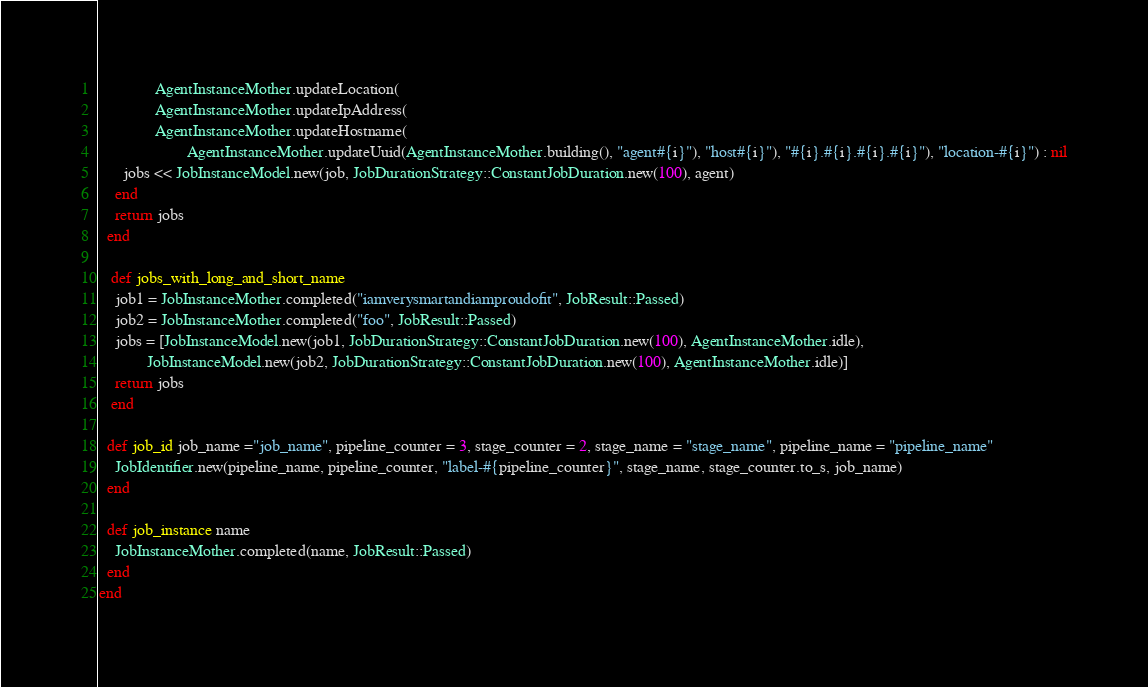Convert code to text. <code><loc_0><loc_0><loc_500><loc_500><_Ruby_>              AgentInstanceMother.updateLocation(
              AgentInstanceMother.updateIpAddress(
              AgentInstanceMother.updateHostname(
                      AgentInstanceMother.updateUuid(AgentInstanceMother.building(), "agent#{i}"), "host#{i}"), "#{i}.#{i}.#{i}.#{i}"), "location-#{i}") : nil
      jobs << JobInstanceModel.new(job, JobDurationStrategy::ConstantJobDuration.new(100), agent)
    end
    return jobs
  end

   def jobs_with_long_and_short_name
    job1 = JobInstanceMother.completed("iamverysmartandiamproudofit", JobResult::Passed)
    job2 = JobInstanceMother.completed("foo", JobResult::Passed)
    jobs = [JobInstanceModel.new(job1, JobDurationStrategy::ConstantJobDuration.new(100), AgentInstanceMother.idle),
            JobInstanceModel.new(job2, JobDurationStrategy::ConstantJobDuration.new(100), AgentInstanceMother.idle)]
    return jobs
   end

  def job_id job_name ="job_name", pipeline_counter = 3, stage_counter = 2, stage_name = "stage_name", pipeline_name = "pipeline_name"
    JobIdentifier.new(pipeline_name, pipeline_counter, "label-#{pipeline_counter}", stage_name, stage_counter.to_s, job_name)
  end

  def job_instance name
    JobInstanceMother.completed(name, JobResult::Passed)
  end
end</code> 